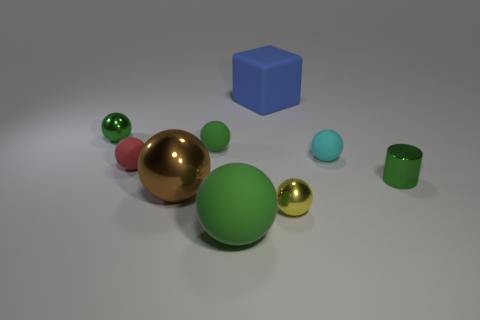Are there any other things that have the same shape as the blue object?
Make the answer very short. No. What number of cyan balls are behind the cyan object?
Provide a short and direct response. 0. Are any tiny blue objects visible?
Ensure brevity in your answer.  No. What is the color of the tiny metal thing behind the tiny green thing that is right of the tiny cyan matte sphere that is behind the shiny cylinder?
Make the answer very short. Green. Is there a small red thing on the left side of the small green object that is to the right of the cube?
Offer a terse response. Yes. Is the color of the large rubber ball in front of the tiny red object the same as the metal sphere behind the big brown thing?
Your answer should be compact. Yes. What number of green metal balls are the same size as the yellow metallic sphere?
Offer a terse response. 1. There is a green shiny object that is to the right of the cyan thing; does it have the same size as the cyan sphere?
Provide a succinct answer. Yes. There is a blue rubber thing; what shape is it?
Make the answer very short. Cube. What size is the metal ball that is the same color as the small metal cylinder?
Give a very brief answer. Small. 